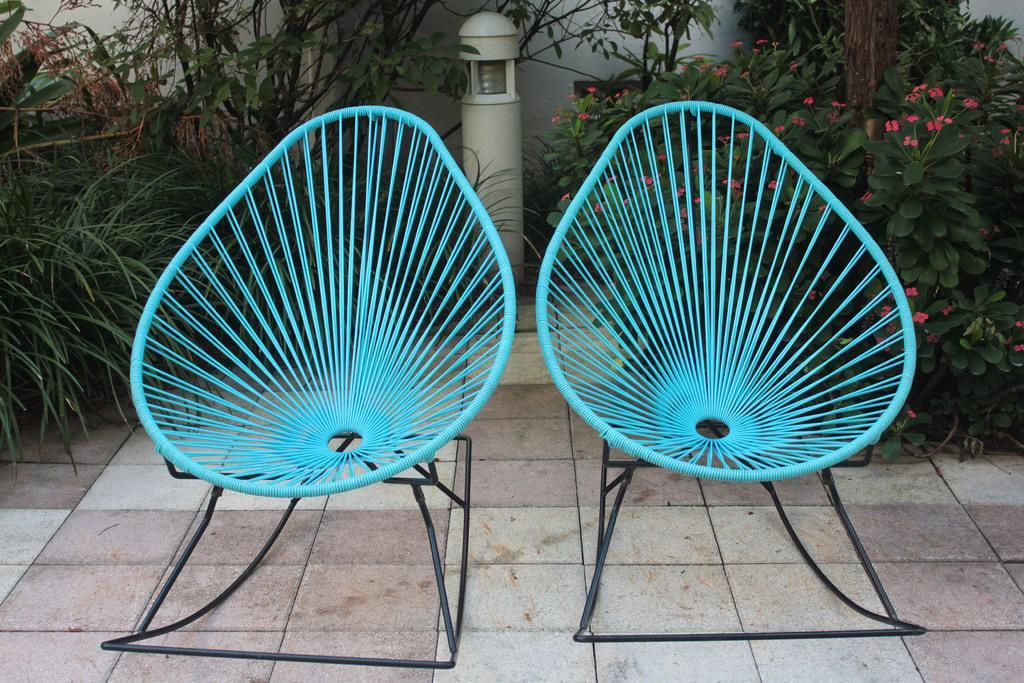In one or two sentences, can you explain what this image depicts? In this picture I can see two chairs in the middle, in the background there are plants. At the top it looks like a light. 